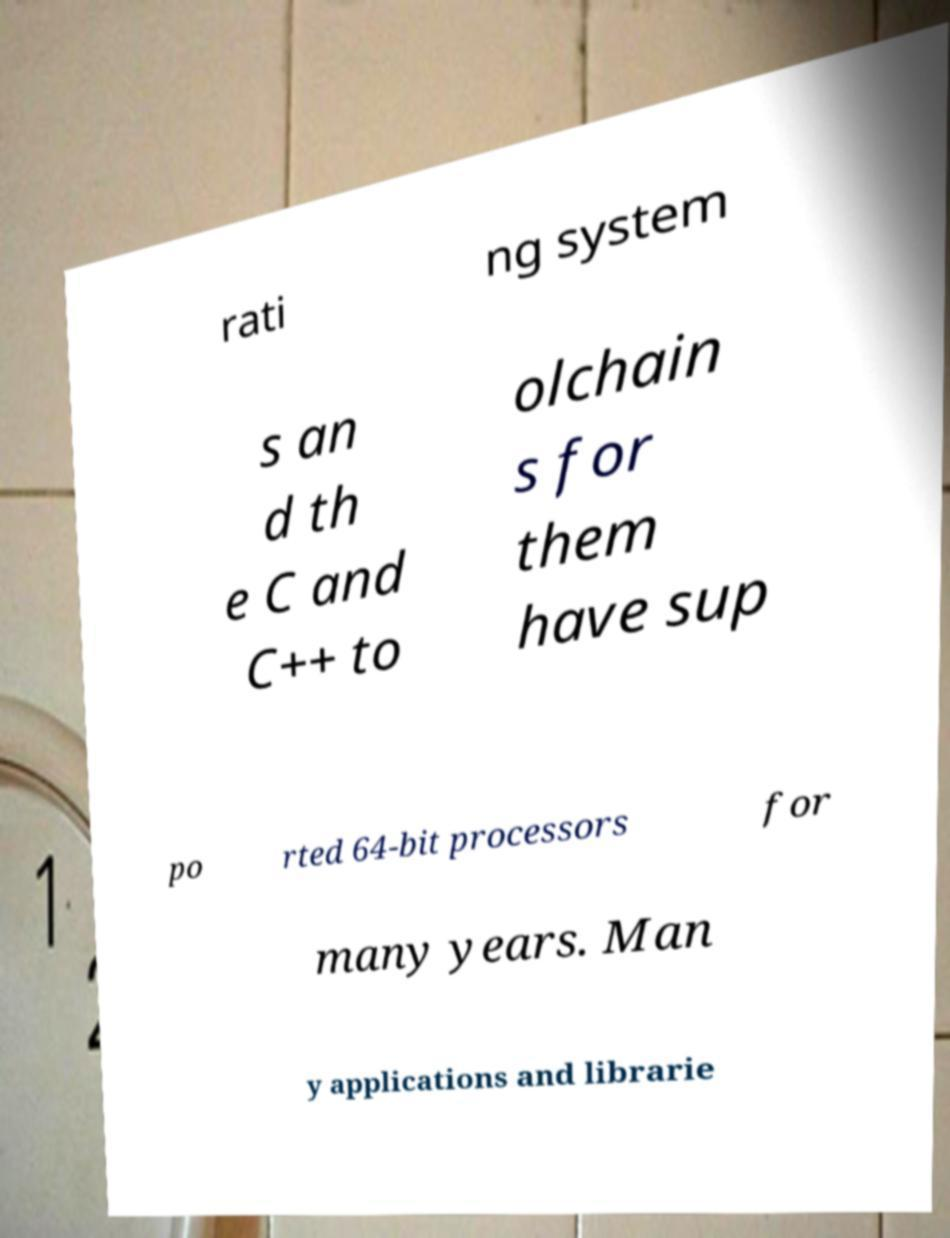I need the written content from this picture converted into text. Can you do that? rati ng system s an d th e C and C++ to olchain s for them have sup po rted 64-bit processors for many years. Man y applications and librarie 